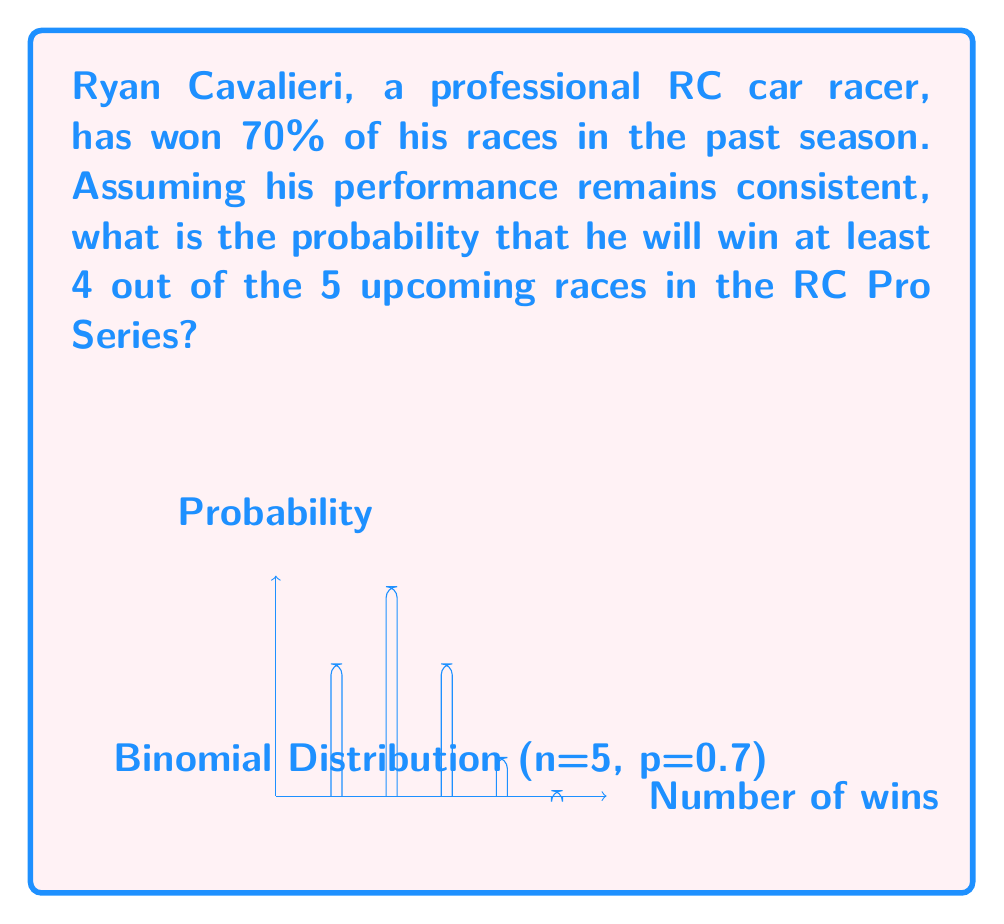Help me with this question. Let's approach this step-by-step:

1) This is a binomial probability problem. We need to find P(X ≥ 4), where X is the number of wins in 5 races.

2) The probability of winning a single race is p = 0.7, and the number of trials is n = 5.

3) We need to calculate P(X = 4) + P(X = 5), as "at least 4" means 4 or 5 wins.

4) The binomial probability formula is:

   $$ P(X = k) = \binom{n}{k} p^k (1-p)^{n-k} $$

5) For P(X = 4):
   $$ P(X = 4) = \binom{5}{4} (0.7)^4 (0.3)^1 = 5 \cdot 0.2401 \cdot 0.3 = 0.36015 $$

6) For P(X = 5):
   $$ P(X = 5) = \binom{5}{5} (0.7)^5 (0.3)^0 = 1 \cdot 0.16807 \cdot 1 = 0.16807 $$

7) Therefore, P(X ≥ 4) = P(X = 4) + P(X = 5) = 0.36015 + 0.16807 = 0.52822
Answer: 0.52822 